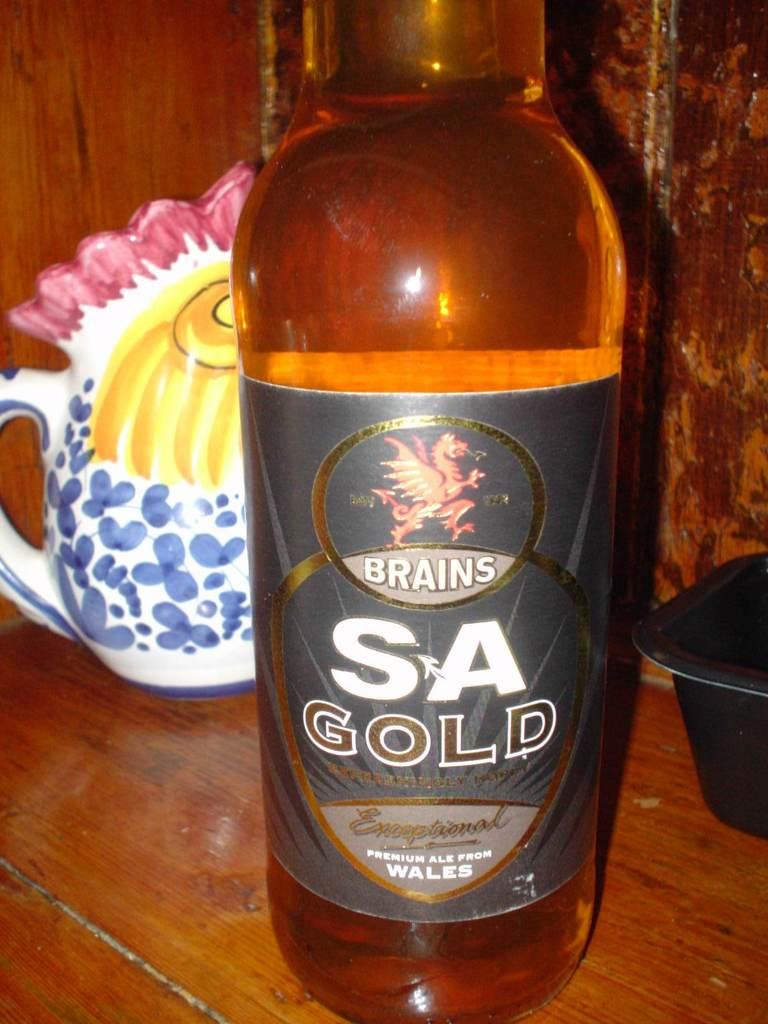<image>
Give a short and clear explanation of the subsequent image. The bottle of beer on the counter-top has a dragon symbol and the label reads Brains. 